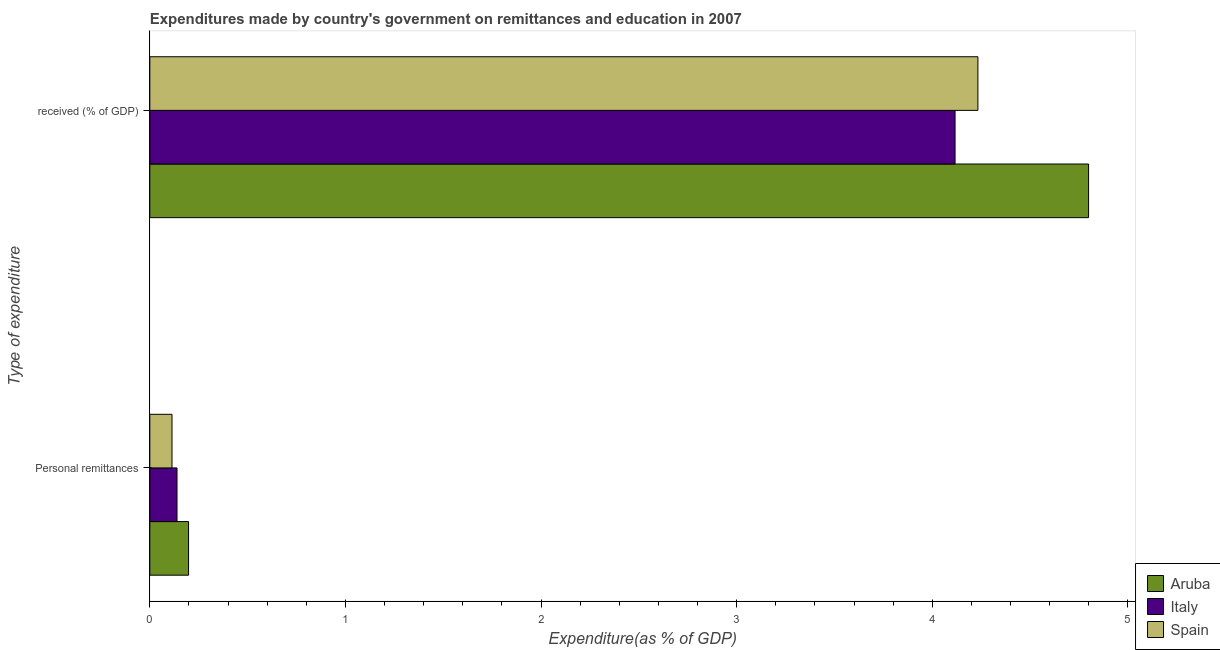Are the number of bars on each tick of the Y-axis equal?
Give a very brief answer. Yes. What is the label of the 2nd group of bars from the top?
Your answer should be compact. Personal remittances. What is the expenditure in education in Spain?
Your response must be concise. 4.23. Across all countries, what is the maximum expenditure in personal remittances?
Your response must be concise. 0.2. Across all countries, what is the minimum expenditure in education?
Make the answer very short. 4.12. In which country was the expenditure in education maximum?
Make the answer very short. Aruba. What is the total expenditure in personal remittances in the graph?
Offer a very short reply. 0.45. What is the difference between the expenditure in personal remittances in Italy and that in Spain?
Your answer should be compact. 0.03. What is the difference between the expenditure in education in Italy and the expenditure in personal remittances in Aruba?
Provide a succinct answer. 3.92. What is the average expenditure in education per country?
Provide a short and direct response. 4.38. What is the difference between the expenditure in personal remittances and expenditure in education in Spain?
Your response must be concise. -4.12. What is the ratio of the expenditure in personal remittances in Aruba to that in Spain?
Your response must be concise. 1.75. What does the 3rd bar from the top in Personal remittances represents?
Your response must be concise. Aruba. What does the 1st bar from the bottom in  received (% of GDP) represents?
Make the answer very short. Aruba. How many bars are there?
Offer a very short reply. 6. What is the difference between two consecutive major ticks on the X-axis?
Make the answer very short. 1. Are the values on the major ticks of X-axis written in scientific E-notation?
Your answer should be very brief. No. Does the graph contain grids?
Your answer should be very brief. No. Where does the legend appear in the graph?
Your response must be concise. Bottom right. What is the title of the graph?
Make the answer very short. Expenditures made by country's government on remittances and education in 2007. Does "Portugal" appear as one of the legend labels in the graph?
Ensure brevity in your answer.  No. What is the label or title of the X-axis?
Keep it short and to the point. Expenditure(as % of GDP). What is the label or title of the Y-axis?
Your answer should be compact. Type of expenditure. What is the Expenditure(as % of GDP) of Aruba in Personal remittances?
Ensure brevity in your answer.  0.2. What is the Expenditure(as % of GDP) in Italy in Personal remittances?
Offer a very short reply. 0.14. What is the Expenditure(as % of GDP) in Spain in Personal remittances?
Ensure brevity in your answer.  0.11. What is the Expenditure(as % of GDP) of Aruba in  received (% of GDP)?
Ensure brevity in your answer.  4.8. What is the Expenditure(as % of GDP) of Italy in  received (% of GDP)?
Offer a terse response. 4.12. What is the Expenditure(as % of GDP) in Spain in  received (% of GDP)?
Offer a very short reply. 4.23. Across all Type of expenditure, what is the maximum Expenditure(as % of GDP) in Aruba?
Offer a very short reply. 4.8. Across all Type of expenditure, what is the maximum Expenditure(as % of GDP) in Italy?
Make the answer very short. 4.12. Across all Type of expenditure, what is the maximum Expenditure(as % of GDP) of Spain?
Provide a short and direct response. 4.23. Across all Type of expenditure, what is the minimum Expenditure(as % of GDP) of Aruba?
Your answer should be very brief. 0.2. Across all Type of expenditure, what is the minimum Expenditure(as % of GDP) in Italy?
Give a very brief answer. 0.14. Across all Type of expenditure, what is the minimum Expenditure(as % of GDP) in Spain?
Provide a short and direct response. 0.11. What is the total Expenditure(as % of GDP) in Aruba in the graph?
Offer a terse response. 5. What is the total Expenditure(as % of GDP) in Italy in the graph?
Provide a succinct answer. 4.26. What is the total Expenditure(as % of GDP) of Spain in the graph?
Offer a terse response. 4.35. What is the difference between the Expenditure(as % of GDP) of Aruba in Personal remittances and that in  received (% of GDP)?
Your answer should be compact. -4.6. What is the difference between the Expenditure(as % of GDP) in Italy in Personal remittances and that in  received (% of GDP)?
Keep it short and to the point. -3.98. What is the difference between the Expenditure(as % of GDP) in Spain in Personal remittances and that in  received (% of GDP)?
Give a very brief answer. -4.12. What is the difference between the Expenditure(as % of GDP) of Aruba in Personal remittances and the Expenditure(as % of GDP) of Italy in  received (% of GDP)?
Give a very brief answer. -3.92. What is the difference between the Expenditure(as % of GDP) in Aruba in Personal remittances and the Expenditure(as % of GDP) in Spain in  received (% of GDP)?
Provide a short and direct response. -4.04. What is the difference between the Expenditure(as % of GDP) in Italy in Personal remittances and the Expenditure(as % of GDP) in Spain in  received (% of GDP)?
Keep it short and to the point. -4.09. What is the average Expenditure(as % of GDP) in Aruba per Type of expenditure?
Your answer should be very brief. 2.5. What is the average Expenditure(as % of GDP) in Italy per Type of expenditure?
Your answer should be very brief. 2.13. What is the average Expenditure(as % of GDP) in Spain per Type of expenditure?
Give a very brief answer. 2.17. What is the difference between the Expenditure(as % of GDP) in Aruba and Expenditure(as % of GDP) in Italy in Personal remittances?
Provide a short and direct response. 0.06. What is the difference between the Expenditure(as % of GDP) of Aruba and Expenditure(as % of GDP) of Spain in Personal remittances?
Provide a succinct answer. 0.08. What is the difference between the Expenditure(as % of GDP) in Italy and Expenditure(as % of GDP) in Spain in Personal remittances?
Your answer should be compact. 0.03. What is the difference between the Expenditure(as % of GDP) of Aruba and Expenditure(as % of GDP) of Italy in  received (% of GDP)?
Provide a short and direct response. 0.68. What is the difference between the Expenditure(as % of GDP) of Aruba and Expenditure(as % of GDP) of Spain in  received (% of GDP)?
Give a very brief answer. 0.57. What is the difference between the Expenditure(as % of GDP) in Italy and Expenditure(as % of GDP) in Spain in  received (% of GDP)?
Make the answer very short. -0.12. What is the ratio of the Expenditure(as % of GDP) in Aruba in Personal remittances to that in  received (% of GDP)?
Provide a short and direct response. 0.04. What is the ratio of the Expenditure(as % of GDP) of Italy in Personal remittances to that in  received (% of GDP)?
Your response must be concise. 0.03. What is the ratio of the Expenditure(as % of GDP) of Spain in Personal remittances to that in  received (% of GDP)?
Provide a short and direct response. 0.03. What is the difference between the highest and the second highest Expenditure(as % of GDP) in Aruba?
Your answer should be very brief. 4.6. What is the difference between the highest and the second highest Expenditure(as % of GDP) in Italy?
Your answer should be very brief. 3.98. What is the difference between the highest and the second highest Expenditure(as % of GDP) of Spain?
Keep it short and to the point. 4.12. What is the difference between the highest and the lowest Expenditure(as % of GDP) in Aruba?
Provide a succinct answer. 4.6. What is the difference between the highest and the lowest Expenditure(as % of GDP) in Italy?
Ensure brevity in your answer.  3.98. What is the difference between the highest and the lowest Expenditure(as % of GDP) of Spain?
Offer a terse response. 4.12. 